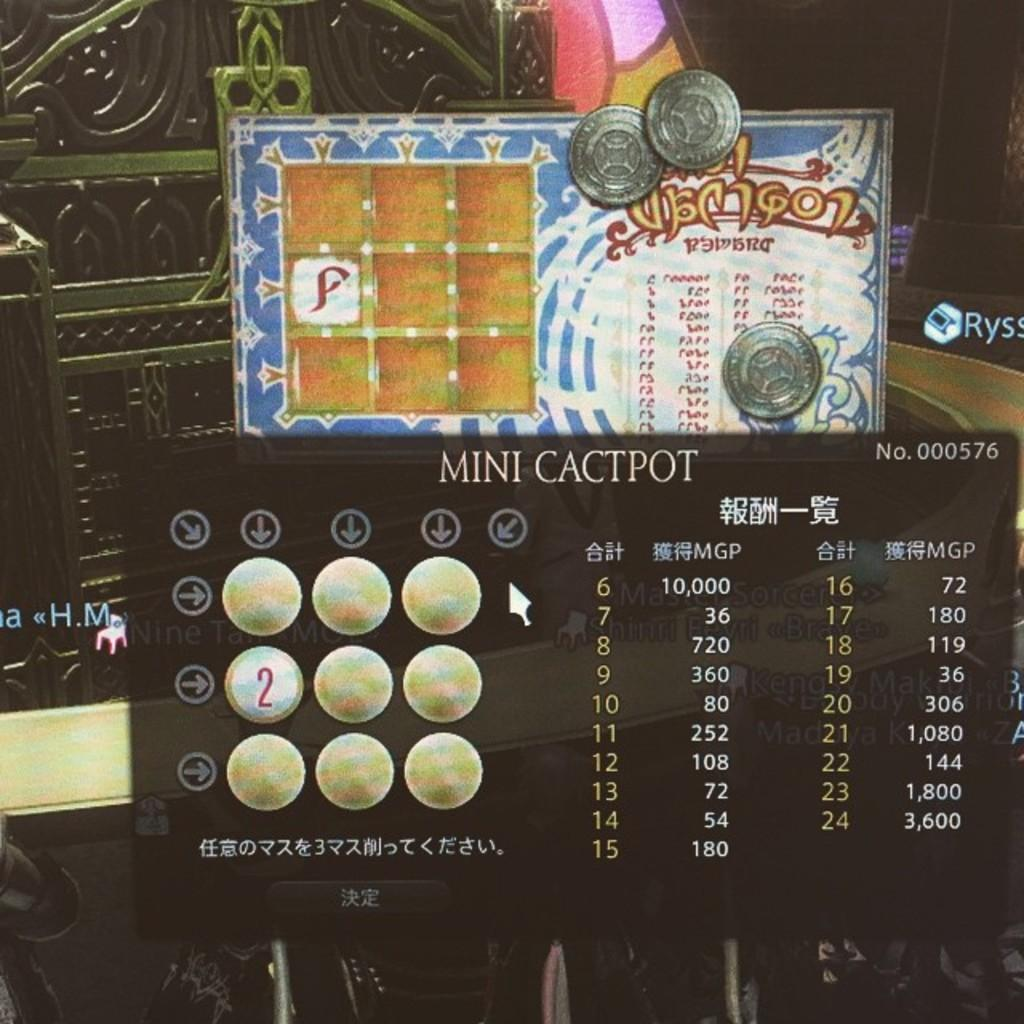<image>
Summarize the visual content of the image. A popup for a game called Mini Cactpot. 